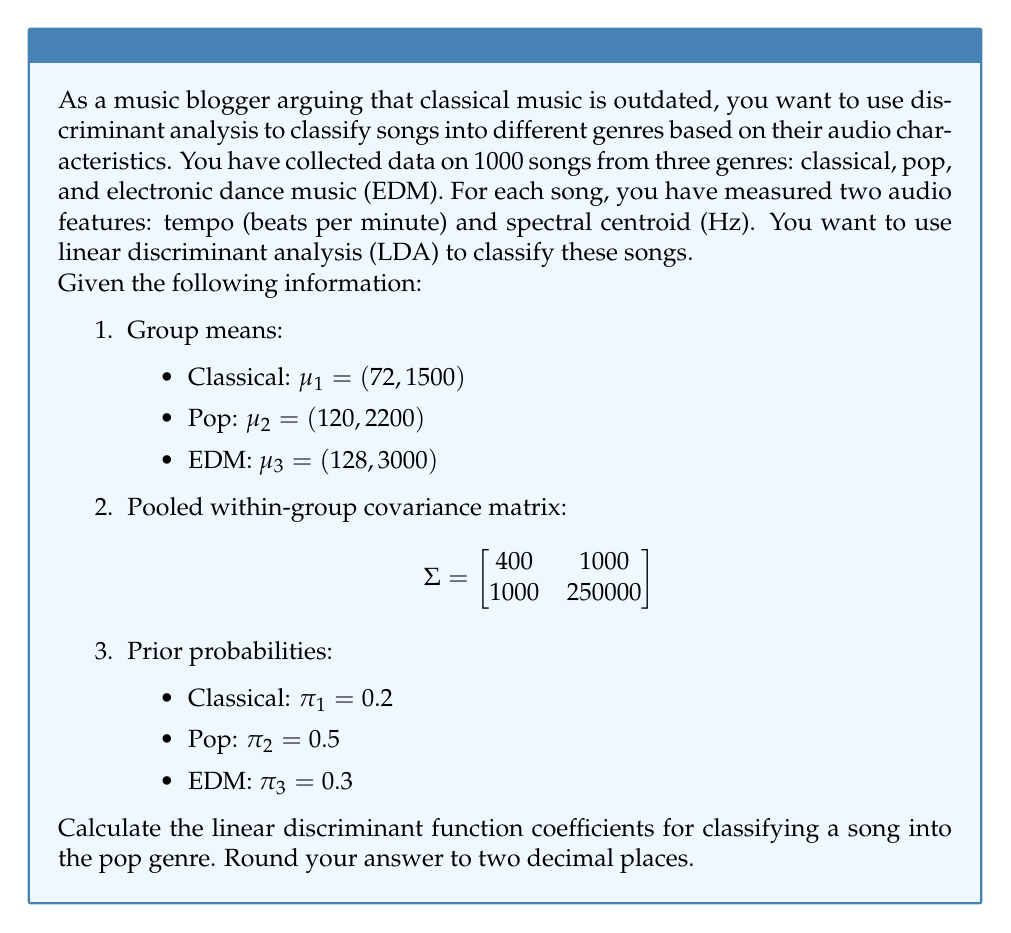Can you answer this question? To solve this problem, we need to follow these steps:

1. Recall the linear discriminant function for group $k$:
   $$\delta_k(x) = x^T \Sigma^{-1}\mu_k - \frac{1}{2}\mu_k^T \Sigma^{-1}\mu_k + \log(\pi_k)$$

2. We need to calculate $\Sigma^{-1}$. The inverse of a 2x2 matrix is given by:
   $$\Sigma^{-1} = \frac{1}{ad-bc}\begin{bmatrix}
   d & -b \\
   -c & a
   \end{bmatrix}$$
   where $a=400$, $b=1000$, $c=1000$, and $d=250000$

   $$\Sigma^{-1} = \frac{1}{400 \cdot 250000 - 1000 \cdot 1000}\begin{bmatrix}
   250000 & -1000 \\
   -1000 & 400
   \end{bmatrix}$$

   $$\Sigma^{-1} = \frac{1}{99000000}\begin{bmatrix}
   250000 & -1000 \\
   -1000 & 400
   \end{bmatrix}$$

3. Now, we focus on the pop genre (k=2). We need to calculate:
   a) $x^T \Sigma^{-1}\mu_2$
   b) $\frac{1}{2}\mu_2^T \Sigma^{-1}\mu_2$
   c) $\log(\pi_2)$

4. For $x^T \Sigma^{-1}\mu_2$:
   $$x^T \Sigma^{-1}\mu_2 = [x_1 \quad x_2] \cdot \frac{1}{99000000}\begin{bmatrix}
   250000 & -1000 \\
   -1000 & 400
   \end{bmatrix} \cdot \begin{bmatrix}
   120 \\
   2200
   \end{bmatrix}$$

   $$= [x_1 \quad x_2] \cdot \frac{1}{99000000}\begin{bmatrix}
   30000000 - 2200000 \\
   -120000 + 880000
   \end{bmatrix}$$

   $$= \frac{1}{99000000}(27800000x_1 + 760000x_2)$$

   $$= 0.2808x_1 + 0.0077x_2$$

5. For $\frac{1}{2}\mu_2^T \Sigma^{-1}\mu_2$:
   $$\frac{1}{2}\mu_2^T \Sigma^{-1}\mu_2 = \frac{1}{2} \cdot [120 \quad 2200] \cdot \frac{1}{99000000}\begin{bmatrix}
   250000 & -1000 \\
   -1000 & 400
   \end{bmatrix} \cdot \begin{bmatrix}
   120 \\
   2200
   \end{bmatrix}$$

   $$= \frac{1}{2} \cdot \frac{1}{99000000} \cdot (3000000000 + 220000000 - 264000000 - 1936000000)$$

   $$= \frac{1}{2} \cdot \frac{1020000000}{99000000} = 5.1515$$

6. For $\log(\pi_2)$:
   $$\log(\pi_2) = \log(0.5) = -0.6931$$

7. Combining these terms, we get the linear discriminant function for pop:
   $$\delta_2(x) = 0.2808x_1 + 0.0077x_2 - 5.1515 - 0.6931$$
   $$\delta_2(x) = 0.2808x_1 + 0.0077x_2 - 5.8446$$

The coefficients of the linear discriminant function for pop are (0.2808, 0.0077, -5.8446).
Answer: (0.28, 0.01, -5.84) 